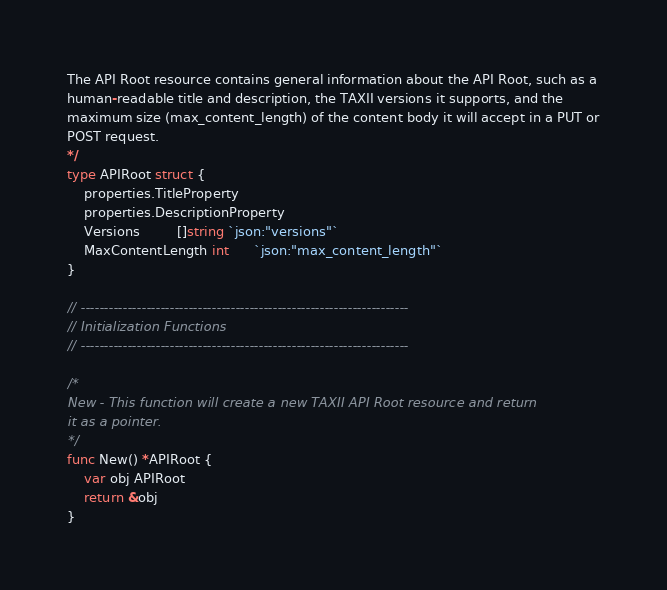Convert code to text. <code><loc_0><loc_0><loc_500><loc_500><_Go_>The API Root resource contains general information about the API Root, such as a
human-readable title and description, the TAXII versions it supports, and the
maximum size (max_content_length) of the content body it will accept in a PUT or
POST request.
*/
type APIRoot struct {
	properties.TitleProperty
	properties.DescriptionProperty
	Versions         []string `json:"versions"`
	MaxContentLength int      `json:"max_content_length"`
}

// ----------------------------------------------------------------------
// Initialization Functions
// ----------------------------------------------------------------------

/*
New - This function will create a new TAXII API Root resource and return
it as a pointer.
*/
func New() *APIRoot {
	var obj APIRoot
	return &obj
}
</code> 